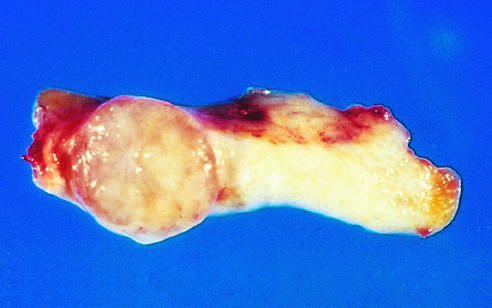s the congo red staining sharply demarcated from the whiter breast tissue?
Answer the question using a single word or phrase. No 